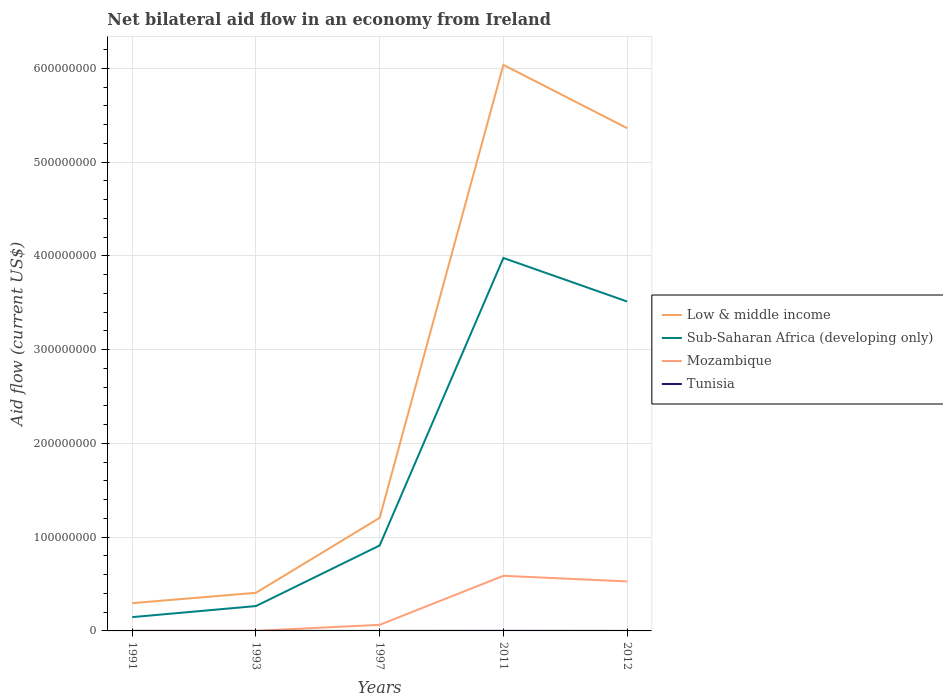Does the line corresponding to Mozambique intersect with the line corresponding to Low & middle income?
Keep it short and to the point. No. Is the number of lines equal to the number of legend labels?
Keep it short and to the point. Yes. In which year was the net bilateral aid flow in Mozambique maximum?
Make the answer very short. 1991. What is the total net bilateral aid flow in Low & middle income in the graph?
Offer a very short reply. -8.00e+07. What is the difference between the highest and the second highest net bilateral aid flow in Mozambique?
Your answer should be very brief. 5.87e+07. Is the net bilateral aid flow in Mozambique strictly greater than the net bilateral aid flow in Sub-Saharan Africa (developing only) over the years?
Your response must be concise. Yes. How many lines are there?
Ensure brevity in your answer.  4. Are the values on the major ticks of Y-axis written in scientific E-notation?
Offer a very short reply. No. Where does the legend appear in the graph?
Make the answer very short. Center right. How many legend labels are there?
Offer a terse response. 4. What is the title of the graph?
Your answer should be very brief. Net bilateral aid flow in an economy from Ireland. What is the label or title of the X-axis?
Your answer should be compact. Years. What is the Aid flow (current US$) in Low & middle income in 1991?
Give a very brief answer. 2.96e+07. What is the Aid flow (current US$) of Sub-Saharan Africa (developing only) in 1991?
Make the answer very short. 1.47e+07. What is the Aid flow (current US$) of Mozambique in 1991?
Give a very brief answer. 1.00e+05. What is the Aid flow (current US$) of Tunisia in 1991?
Make the answer very short. 10000. What is the Aid flow (current US$) of Low & middle income in 1993?
Offer a terse response. 4.07e+07. What is the Aid flow (current US$) of Sub-Saharan Africa (developing only) in 1993?
Your answer should be very brief. 2.65e+07. What is the Aid flow (current US$) of Tunisia in 1993?
Keep it short and to the point. 10000. What is the Aid flow (current US$) of Low & middle income in 1997?
Offer a terse response. 1.21e+08. What is the Aid flow (current US$) in Sub-Saharan Africa (developing only) in 1997?
Give a very brief answer. 9.11e+07. What is the Aid flow (current US$) in Mozambique in 1997?
Make the answer very short. 6.48e+06. What is the Aid flow (current US$) in Tunisia in 1997?
Your answer should be compact. 2.00e+04. What is the Aid flow (current US$) in Low & middle income in 2011?
Make the answer very short. 6.04e+08. What is the Aid flow (current US$) in Sub-Saharan Africa (developing only) in 2011?
Your answer should be compact. 3.98e+08. What is the Aid flow (current US$) in Mozambique in 2011?
Keep it short and to the point. 5.88e+07. What is the Aid flow (current US$) of Tunisia in 2011?
Offer a very short reply. 8.00e+04. What is the Aid flow (current US$) of Low & middle income in 2012?
Your response must be concise. 5.36e+08. What is the Aid flow (current US$) in Sub-Saharan Africa (developing only) in 2012?
Offer a terse response. 3.51e+08. What is the Aid flow (current US$) in Mozambique in 2012?
Give a very brief answer. 5.28e+07. Across all years, what is the maximum Aid flow (current US$) of Low & middle income?
Your response must be concise. 6.04e+08. Across all years, what is the maximum Aid flow (current US$) in Sub-Saharan Africa (developing only)?
Make the answer very short. 3.98e+08. Across all years, what is the maximum Aid flow (current US$) of Mozambique?
Provide a succinct answer. 5.88e+07. Across all years, what is the maximum Aid flow (current US$) of Tunisia?
Make the answer very short. 8.00e+04. Across all years, what is the minimum Aid flow (current US$) of Low & middle income?
Provide a short and direct response. 2.96e+07. Across all years, what is the minimum Aid flow (current US$) of Sub-Saharan Africa (developing only)?
Offer a very short reply. 1.47e+07. Across all years, what is the minimum Aid flow (current US$) of Tunisia?
Your answer should be very brief. 10000. What is the total Aid flow (current US$) in Low & middle income in the graph?
Give a very brief answer. 1.33e+09. What is the total Aid flow (current US$) in Sub-Saharan Africa (developing only) in the graph?
Give a very brief answer. 8.81e+08. What is the total Aid flow (current US$) in Mozambique in the graph?
Keep it short and to the point. 1.18e+08. What is the total Aid flow (current US$) of Tunisia in the graph?
Offer a very short reply. 1.30e+05. What is the difference between the Aid flow (current US$) of Low & middle income in 1991 and that in 1993?
Make the answer very short. -1.10e+07. What is the difference between the Aid flow (current US$) in Sub-Saharan Africa (developing only) in 1991 and that in 1993?
Ensure brevity in your answer.  -1.18e+07. What is the difference between the Aid flow (current US$) of Tunisia in 1991 and that in 1993?
Your answer should be very brief. 0. What is the difference between the Aid flow (current US$) of Low & middle income in 1991 and that in 1997?
Give a very brief answer. -9.10e+07. What is the difference between the Aid flow (current US$) in Sub-Saharan Africa (developing only) in 1991 and that in 1997?
Your response must be concise. -7.64e+07. What is the difference between the Aid flow (current US$) in Mozambique in 1991 and that in 1997?
Offer a very short reply. -6.38e+06. What is the difference between the Aid flow (current US$) in Tunisia in 1991 and that in 1997?
Your answer should be very brief. -10000. What is the difference between the Aid flow (current US$) in Low & middle income in 1991 and that in 2011?
Give a very brief answer. -5.74e+08. What is the difference between the Aid flow (current US$) in Sub-Saharan Africa (developing only) in 1991 and that in 2011?
Make the answer very short. -3.83e+08. What is the difference between the Aid flow (current US$) in Mozambique in 1991 and that in 2011?
Keep it short and to the point. -5.87e+07. What is the difference between the Aid flow (current US$) in Tunisia in 1991 and that in 2011?
Your response must be concise. -7.00e+04. What is the difference between the Aid flow (current US$) of Low & middle income in 1991 and that in 2012?
Make the answer very short. -5.07e+08. What is the difference between the Aid flow (current US$) of Sub-Saharan Africa (developing only) in 1991 and that in 2012?
Provide a short and direct response. -3.37e+08. What is the difference between the Aid flow (current US$) of Mozambique in 1991 and that in 2012?
Keep it short and to the point. -5.27e+07. What is the difference between the Aid flow (current US$) of Tunisia in 1991 and that in 2012?
Provide a succinct answer. 0. What is the difference between the Aid flow (current US$) of Low & middle income in 1993 and that in 1997?
Ensure brevity in your answer.  -8.00e+07. What is the difference between the Aid flow (current US$) of Sub-Saharan Africa (developing only) in 1993 and that in 1997?
Ensure brevity in your answer.  -6.46e+07. What is the difference between the Aid flow (current US$) of Mozambique in 1993 and that in 1997?
Give a very brief answer. -6.36e+06. What is the difference between the Aid flow (current US$) in Low & middle income in 1993 and that in 2011?
Give a very brief answer. -5.63e+08. What is the difference between the Aid flow (current US$) of Sub-Saharan Africa (developing only) in 1993 and that in 2011?
Offer a terse response. -3.71e+08. What is the difference between the Aid flow (current US$) of Mozambique in 1993 and that in 2011?
Your response must be concise. -5.87e+07. What is the difference between the Aid flow (current US$) of Low & middle income in 1993 and that in 2012?
Provide a succinct answer. -4.96e+08. What is the difference between the Aid flow (current US$) in Sub-Saharan Africa (developing only) in 1993 and that in 2012?
Your answer should be very brief. -3.25e+08. What is the difference between the Aid flow (current US$) of Mozambique in 1993 and that in 2012?
Make the answer very short. -5.27e+07. What is the difference between the Aid flow (current US$) in Tunisia in 1993 and that in 2012?
Keep it short and to the point. 0. What is the difference between the Aid flow (current US$) in Low & middle income in 1997 and that in 2011?
Your answer should be compact. -4.83e+08. What is the difference between the Aid flow (current US$) of Sub-Saharan Africa (developing only) in 1997 and that in 2011?
Offer a very short reply. -3.07e+08. What is the difference between the Aid flow (current US$) of Mozambique in 1997 and that in 2011?
Your response must be concise. -5.23e+07. What is the difference between the Aid flow (current US$) in Low & middle income in 1997 and that in 2012?
Offer a very short reply. -4.16e+08. What is the difference between the Aid flow (current US$) of Sub-Saharan Africa (developing only) in 1997 and that in 2012?
Provide a short and direct response. -2.60e+08. What is the difference between the Aid flow (current US$) in Mozambique in 1997 and that in 2012?
Your response must be concise. -4.63e+07. What is the difference between the Aid flow (current US$) of Low & middle income in 2011 and that in 2012?
Give a very brief answer. 6.75e+07. What is the difference between the Aid flow (current US$) of Sub-Saharan Africa (developing only) in 2011 and that in 2012?
Give a very brief answer. 4.64e+07. What is the difference between the Aid flow (current US$) of Mozambique in 2011 and that in 2012?
Offer a terse response. 5.98e+06. What is the difference between the Aid flow (current US$) in Low & middle income in 1991 and the Aid flow (current US$) in Sub-Saharan Africa (developing only) in 1993?
Offer a terse response. 3.12e+06. What is the difference between the Aid flow (current US$) in Low & middle income in 1991 and the Aid flow (current US$) in Mozambique in 1993?
Offer a terse response. 2.95e+07. What is the difference between the Aid flow (current US$) of Low & middle income in 1991 and the Aid flow (current US$) of Tunisia in 1993?
Keep it short and to the point. 2.96e+07. What is the difference between the Aid flow (current US$) of Sub-Saharan Africa (developing only) in 1991 and the Aid flow (current US$) of Mozambique in 1993?
Keep it short and to the point. 1.46e+07. What is the difference between the Aid flow (current US$) of Sub-Saharan Africa (developing only) in 1991 and the Aid flow (current US$) of Tunisia in 1993?
Provide a short and direct response. 1.47e+07. What is the difference between the Aid flow (current US$) in Mozambique in 1991 and the Aid flow (current US$) in Tunisia in 1993?
Provide a short and direct response. 9.00e+04. What is the difference between the Aid flow (current US$) in Low & middle income in 1991 and the Aid flow (current US$) in Sub-Saharan Africa (developing only) in 1997?
Your answer should be very brief. -6.15e+07. What is the difference between the Aid flow (current US$) of Low & middle income in 1991 and the Aid flow (current US$) of Mozambique in 1997?
Offer a very short reply. 2.32e+07. What is the difference between the Aid flow (current US$) of Low & middle income in 1991 and the Aid flow (current US$) of Tunisia in 1997?
Your response must be concise. 2.96e+07. What is the difference between the Aid flow (current US$) in Sub-Saharan Africa (developing only) in 1991 and the Aid flow (current US$) in Mozambique in 1997?
Provide a short and direct response. 8.24e+06. What is the difference between the Aid flow (current US$) of Sub-Saharan Africa (developing only) in 1991 and the Aid flow (current US$) of Tunisia in 1997?
Ensure brevity in your answer.  1.47e+07. What is the difference between the Aid flow (current US$) in Low & middle income in 1991 and the Aid flow (current US$) in Sub-Saharan Africa (developing only) in 2011?
Your answer should be very brief. -3.68e+08. What is the difference between the Aid flow (current US$) in Low & middle income in 1991 and the Aid flow (current US$) in Mozambique in 2011?
Provide a short and direct response. -2.92e+07. What is the difference between the Aid flow (current US$) in Low & middle income in 1991 and the Aid flow (current US$) in Tunisia in 2011?
Your answer should be very brief. 2.96e+07. What is the difference between the Aid flow (current US$) in Sub-Saharan Africa (developing only) in 1991 and the Aid flow (current US$) in Mozambique in 2011?
Your response must be concise. -4.41e+07. What is the difference between the Aid flow (current US$) of Sub-Saharan Africa (developing only) in 1991 and the Aid flow (current US$) of Tunisia in 2011?
Your answer should be compact. 1.46e+07. What is the difference between the Aid flow (current US$) of Mozambique in 1991 and the Aid flow (current US$) of Tunisia in 2011?
Keep it short and to the point. 2.00e+04. What is the difference between the Aid flow (current US$) of Low & middle income in 1991 and the Aid flow (current US$) of Sub-Saharan Africa (developing only) in 2012?
Your answer should be compact. -3.22e+08. What is the difference between the Aid flow (current US$) in Low & middle income in 1991 and the Aid flow (current US$) in Mozambique in 2012?
Offer a very short reply. -2.32e+07. What is the difference between the Aid flow (current US$) in Low & middle income in 1991 and the Aid flow (current US$) in Tunisia in 2012?
Make the answer very short. 2.96e+07. What is the difference between the Aid flow (current US$) of Sub-Saharan Africa (developing only) in 1991 and the Aid flow (current US$) of Mozambique in 2012?
Provide a short and direct response. -3.81e+07. What is the difference between the Aid flow (current US$) of Sub-Saharan Africa (developing only) in 1991 and the Aid flow (current US$) of Tunisia in 2012?
Make the answer very short. 1.47e+07. What is the difference between the Aid flow (current US$) in Mozambique in 1991 and the Aid flow (current US$) in Tunisia in 2012?
Your answer should be compact. 9.00e+04. What is the difference between the Aid flow (current US$) in Low & middle income in 1993 and the Aid flow (current US$) in Sub-Saharan Africa (developing only) in 1997?
Ensure brevity in your answer.  -5.05e+07. What is the difference between the Aid flow (current US$) of Low & middle income in 1993 and the Aid flow (current US$) of Mozambique in 1997?
Give a very brief answer. 3.42e+07. What is the difference between the Aid flow (current US$) of Low & middle income in 1993 and the Aid flow (current US$) of Tunisia in 1997?
Your answer should be very brief. 4.06e+07. What is the difference between the Aid flow (current US$) of Sub-Saharan Africa (developing only) in 1993 and the Aid flow (current US$) of Mozambique in 1997?
Give a very brief answer. 2.00e+07. What is the difference between the Aid flow (current US$) in Sub-Saharan Africa (developing only) in 1993 and the Aid flow (current US$) in Tunisia in 1997?
Make the answer very short. 2.65e+07. What is the difference between the Aid flow (current US$) of Mozambique in 1993 and the Aid flow (current US$) of Tunisia in 1997?
Your answer should be compact. 1.00e+05. What is the difference between the Aid flow (current US$) in Low & middle income in 1993 and the Aid flow (current US$) in Sub-Saharan Africa (developing only) in 2011?
Keep it short and to the point. -3.57e+08. What is the difference between the Aid flow (current US$) in Low & middle income in 1993 and the Aid flow (current US$) in Mozambique in 2011?
Your response must be concise. -1.81e+07. What is the difference between the Aid flow (current US$) in Low & middle income in 1993 and the Aid flow (current US$) in Tunisia in 2011?
Keep it short and to the point. 4.06e+07. What is the difference between the Aid flow (current US$) of Sub-Saharan Africa (developing only) in 1993 and the Aid flow (current US$) of Mozambique in 2011?
Your response must be concise. -3.23e+07. What is the difference between the Aid flow (current US$) of Sub-Saharan Africa (developing only) in 1993 and the Aid flow (current US$) of Tunisia in 2011?
Your answer should be very brief. 2.64e+07. What is the difference between the Aid flow (current US$) of Mozambique in 1993 and the Aid flow (current US$) of Tunisia in 2011?
Give a very brief answer. 4.00e+04. What is the difference between the Aid flow (current US$) of Low & middle income in 1993 and the Aid flow (current US$) of Sub-Saharan Africa (developing only) in 2012?
Your answer should be compact. -3.11e+08. What is the difference between the Aid flow (current US$) of Low & middle income in 1993 and the Aid flow (current US$) of Mozambique in 2012?
Keep it short and to the point. -1.21e+07. What is the difference between the Aid flow (current US$) in Low & middle income in 1993 and the Aid flow (current US$) in Tunisia in 2012?
Your response must be concise. 4.06e+07. What is the difference between the Aid flow (current US$) in Sub-Saharan Africa (developing only) in 1993 and the Aid flow (current US$) in Mozambique in 2012?
Give a very brief answer. -2.63e+07. What is the difference between the Aid flow (current US$) of Sub-Saharan Africa (developing only) in 1993 and the Aid flow (current US$) of Tunisia in 2012?
Offer a terse response. 2.65e+07. What is the difference between the Aid flow (current US$) in Low & middle income in 1997 and the Aid flow (current US$) in Sub-Saharan Africa (developing only) in 2011?
Ensure brevity in your answer.  -2.77e+08. What is the difference between the Aid flow (current US$) of Low & middle income in 1997 and the Aid flow (current US$) of Mozambique in 2011?
Give a very brief answer. 6.18e+07. What is the difference between the Aid flow (current US$) of Low & middle income in 1997 and the Aid flow (current US$) of Tunisia in 2011?
Your response must be concise. 1.21e+08. What is the difference between the Aid flow (current US$) in Sub-Saharan Africa (developing only) in 1997 and the Aid flow (current US$) in Mozambique in 2011?
Provide a succinct answer. 3.24e+07. What is the difference between the Aid flow (current US$) of Sub-Saharan Africa (developing only) in 1997 and the Aid flow (current US$) of Tunisia in 2011?
Offer a very short reply. 9.10e+07. What is the difference between the Aid flow (current US$) of Mozambique in 1997 and the Aid flow (current US$) of Tunisia in 2011?
Your answer should be very brief. 6.40e+06. What is the difference between the Aid flow (current US$) in Low & middle income in 1997 and the Aid flow (current US$) in Sub-Saharan Africa (developing only) in 2012?
Ensure brevity in your answer.  -2.31e+08. What is the difference between the Aid flow (current US$) in Low & middle income in 1997 and the Aid flow (current US$) in Mozambique in 2012?
Provide a succinct answer. 6.78e+07. What is the difference between the Aid flow (current US$) of Low & middle income in 1997 and the Aid flow (current US$) of Tunisia in 2012?
Offer a very short reply. 1.21e+08. What is the difference between the Aid flow (current US$) of Sub-Saharan Africa (developing only) in 1997 and the Aid flow (current US$) of Mozambique in 2012?
Offer a very short reply. 3.83e+07. What is the difference between the Aid flow (current US$) of Sub-Saharan Africa (developing only) in 1997 and the Aid flow (current US$) of Tunisia in 2012?
Offer a terse response. 9.11e+07. What is the difference between the Aid flow (current US$) of Mozambique in 1997 and the Aid flow (current US$) of Tunisia in 2012?
Your response must be concise. 6.47e+06. What is the difference between the Aid flow (current US$) in Low & middle income in 2011 and the Aid flow (current US$) in Sub-Saharan Africa (developing only) in 2012?
Your answer should be compact. 2.52e+08. What is the difference between the Aid flow (current US$) of Low & middle income in 2011 and the Aid flow (current US$) of Mozambique in 2012?
Offer a very short reply. 5.51e+08. What is the difference between the Aid flow (current US$) of Low & middle income in 2011 and the Aid flow (current US$) of Tunisia in 2012?
Your answer should be very brief. 6.04e+08. What is the difference between the Aid flow (current US$) of Sub-Saharan Africa (developing only) in 2011 and the Aid flow (current US$) of Mozambique in 2012?
Your response must be concise. 3.45e+08. What is the difference between the Aid flow (current US$) of Sub-Saharan Africa (developing only) in 2011 and the Aid flow (current US$) of Tunisia in 2012?
Offer a very short reply. 3.98e+08. What is the difference between the Aid flow (current US$) of Mozambique in 2011 and the Aid flow (current US$) of Tunisia in 2012?
Provide a succinct answer. 5.88e+07. What is the average Aid flow (current US$) of Low & middle income per year?
Offer a very short reply. 2.66e+08. What is the average Aid flow (current US$) of Sub-Saharan Africa (developing only) per year?
Give a very brief answer. 1.76e+08. What is the average Aid flow (current US$) in Mozambique per year?
Your answer should be compact. 2.37e+07. What is the average Aid flow (current US$) in Tunisia per year?
Make the answer very short. 2.60e+04. In the year 1991, what is the difference between the Aid flow (current US$) in Low & middle income and Aid flow (current US$) in Sub-Saharan Africa (developing only)?
Provide a succinct answer. 1.49e+07. In the year 1991, what is the difference between the Aid flow (current US$) in Low & middle income and Aid flow (current US$) in Mozambique?
Provide a succinct answer. 2.95e+07. In the year 1991, what is the difference between the Aid flow (current US$) in Low & middle income and Aid flow (current US$) in Tunisia?
Provide a short and direct response. 2.96e+07. In the year 1991, what is the difference between the Aid flow (current US$) of Sub-Saharan Africa (developing only) and Aid flow (current US$) of Mozambique?
Provide a short and direct response. 1.46e+07. In the year 1991, what is the difference between the Aid flow (current US$) in Sub-Saharan Africa (developing only) and Aid flow (current US$) in Tunisia?
Your answer should be compact. 1.47e+07. In the year 1991, what is the difference between the Aid flow (current US$) of Mozambique and Aid flow (current US$) of Tunisia?
Provide a succinct answer. 9.00e+04. In the year 1993, what is the difference between the Aid flow (current US$) in Low & middle income and Aid flow (current US$) in Sub-Saharan Africa (developing only)?
Give a very brief answer. 1.42e+07. In the year 1993, what is the difference between the Aid flow (current US$) in Low & middle income and Aid flow (current US$) in Mozambique?
Offer a terse response. 4.05e+07. In the year 1993, what is the difference between the Aid flow (current US$) in Low & middle income and Aid flow (current US$) in Tunisia?
Provide a short and direct response. 4.06e+07. In the year 1993, what is the difference between the Aid flow (current US$) of Sub-Saharan Africa (developing only) and Aid flow (current US$) of Mozambique?
Your response must be concise. 2.64e+07. In the year 1993, what is the difference between the Aid flow (current US$) of Sub-Saharan Africa (developing only) and Aid flow (current US$) of Tunisia?
Offer a terse response. 2.65e+07. In the year 1993, what is the difference between the Aid flow (current US$) of Mozambique and Aid flow (current US$) of Tunisia?
Your answer should be compact. 1.10e+05. In the year 1997, what is the difference between the Aid flow (current US$) of Low & middle income and Aid flow (current US$) of Sub-Saharan Africa (developing only)?
Your response must be concise. 2.95e+07. In the year 1997, what is the difference between the Aid flow (current US$) in Low & middle income and Aid flow (current US$) in Mozambique?
Your response must be concise. 1.14e+08. In the year 1997, what is the difference between the Aid flow (current US$) of Low & middle income and Aid flow (current US$) of Tunisia?
Provide a short and direct response. 1.21e+08. In the year 1997, what is the difference between the Aid flow (current US$) in Sub-Saharan Africa (developing only) and Aid flow (current US$) in Mozambique?
Your response must be concise. 8.46e+07. In the year 1997, what is the difference between the Aid flow (current US$) of Sub-Saharan Africa (developing only) and Aid flow (current US$) of Tunisia?
Provide a short and direct response. 9.11e+07. In the year 1997, what is the difference between the Aid flow (current US$) of Mozambique and Aid flow (current US$) of Tunisia?
Offer a terse response. 6.46e+06. In the year 2011, what is the difference between the Aid flow (current US$) in Low & middle income and Aid flow (current US$) in Sub-Saharan Africa (developing only)?
Provide a short and direct response. 2.06e+08. In the year 2011, what is the difference between the Aid flow (current US$) in Low & middle income and Aid flow (current US$) in Mozambique?
Provide a succinct answer. 5.45e+08. In the year 2011, what is the difference between the Aid flow (current US$) in Low & middle income and Aid flow (current US$) in Tunisia?
Your answer should be compact. 6.04e+08. In the year 2011, what is the difference between the Aid flow (current US$) of Sub-Saharan Africa (developing only) and Aid flow (current US$) of Mozambique?
Offer a very short reply. 3.39e+08. In the year 2011, what is the difference between the Aid flow (current US$) of Sub-Saharan Africa (developing only) and Aid flow (current US$) of Tunisia?
Make the answer very short. 3.98e+08. In the year 2011, what is the difference between the Aid flow (current US$) of Mozambique and Aid flow (current US$) of Tunisia?
Provide a succinct answer. 5.87e+07. In the year 2012, what is the difference between the Aid flow (current US$) in Low & middle income and Aid flow (current US$) in Sub-Saharan Africa (developing only)?
Provide a short and direct response. 1.85e+08. In the year 2012, what is the difference between the Aid flow (current US$) in Low & middle income and Aid flow (current US$) in Mozambique?
Provide a succinct answer. 4.83e+08. In the year 2012, what is the difference between the Aid flow (current US$) in Low & middle income and Aid flow (current US$) in Tunisia?
Ensure brevity in your answer.  5.36e+08. In the year 2012, what is the difference between the Aid flow (current US$) of Sub-Saharan Africa (developing only) and Aid flow (current US$) of Mozambique?
Keep it short and to the point. 2.99e+08. In the year 2012, what is the difference between the Aid flow (current US$) of Sub-Saharan Africa (developing only) and Aid flow (current US$) of Tunisia?
Provide a succinct answer. 3.51e+08. In the year 2012, what is the difference between the Aid flow (current US$) in Mozambique and Aid flow (current US$) in Tunisia?
Offer a very short reply. 5.28e+07. What is the ratio of the Aid flow (current US$) in Low & middle income in 1991 to that in 1993?
Provide a succinct answer. 0.73. What is the ratio of the Aid flow (current US$) of Sub-Saharan Africa (developing only) in 1991 to that in 1993?
Provide a succinct answer. 0.56. What is the ratio of the Aid flow (current US$) of Tunisia in 1991 to that in 1993?
Give a very brief answer. 1. What is the ratio of the Aid flow (current US$) of Low & middle income in 1991 to that in 1997?
Make the answer very short. 0.25. What is the ratio of the Aid flow (current US$) of Sub-Saharan Africa (developing only) in 1991 to that in 1997?
Offer a very short reply. 0.16. What is the ratio of the Aid flow (current US$) of Mozambique in 1991 to that in 1997?
Your answer should be compact. 0.02. What is the ratio of the Aid flow (current US$) of Low & middle income in 1991 to that in 2011?
Give a very brief answer. 0.05. What is the ratio of the Aid flow (current US$) in Sub-Saharan Africa (developing only) in 1991 to that in 2011?
Your answer should be very brief. 0.04. What is the ratio of the Aid flow (current US$) of Mozambique in 1991 to that in 2011?
Offer a very short reply. 0. What is the ratio of the Aid flow (current US$) in Tunisia in 1991 to that in 2011?
Keep it short and to the point. 0.12. What is the ratio of the Aid flow (current US$) of Low & middle income in 1991 to that in 2012?
Offer a very short reply. 0.06. What is the ratio of the Aid flow (current US$) in Sub-Saharan Africa (developing only) in 1991 to that in 2012?
Provide a short and direct response. 0.04. What is the ratio of the Aid flow (current US$) in Mozambique in 1991 to that in 2012?
Your answer should be very brief. 0. What is the ratio of the Aid flow (current US$) of Low & middle income in 1993 to that in 1997?
Make the answer very short. 0.34. What is the ratio of the Aid flow (current US$) in Sub-Saharan Africa (developing only) in 1993 to that in 1997?
Keep it short and to the point. 0.29. What is the ratio of the Aid flow (current US$) of Mozambique in 1993 to that in 1997?
Your answer should be compact. 0.02. What is the ratio of the Aid flow (current US$) of Tunisia in 1993 to that in 1997?
Provide a succinct answer. 0.5. What is the ratio of the Aid flow (current US$) of Low & middle income in 1993 to that in 2011?
Provide a short and direct response. 0.07. What is the ratio of the Aid flow (current US$) of Sub-Saharan Africa (developing only) in 1993 to that in 2011?
Keep it short and to the point. 0.07. What is the ratio of the Aid flow (current US$) in Mozambique in 1993 to that in 2011?
Your answer should be compact. 0. What is the ratio of the Aid flow (current US$) of Tunisia in 1993 to that in 2011?
Make the answer very short. 0.12. What is the ratio of the Aid flow (current US$) of Low & middle income in 1993 to that in 2012?
Your answer should be compact. 0.08. What is the ratio of the Aid flow (current US$) of Sub-Saharan Africa (developing only) in 1993 to that in 2012?
Provide a short and direct response. 0.08. What is the ratio of the Aid flow (current US$) in Mozambique in 1993 to that in 2012?
Your answer should be compact. 0. What is the ratio of the Aid flow (current US$) of Low & middle income in 1997 to that in 2011?
Your response must be concise. 0.2. What is the ratio of the Aid flow (current US$) in Sub-Saharan Africa (developing only) in 1997 to that in 2011?
Provide a succinct answer. 0.23. What is the ratio of the Aid flow (current US$) in Mozambique in 1997 to that in 2011?
Offer a terse response. 0.11. What is the ratio of the Aid flow (current US$) of Low & middle income in 1997 to that in 2012?
Offer a terse response. 0.23. What is the ratio of the Aid flow (current US$) of Sub-Saharan Africa (developing only) in 1997 to that in 2012?
Keep it short and to the point. 0.26. What is the ratio of the Aid flow (current US$) in Mozambique in 1997 to that in 2012?
Provide a short and direct response. 0.12. What is the ratio of the Aid flow (current US$) in Low & middle income in 2011 to that in 2012?
Your response must be concise. 1.13. What is the ratio of the Aid flow (current US$) in Sub-Saharan Africa (developing only) in 2011 to that in 2012?
Give a very brief answer. 1.13. What is the ratio of the Aid flow (current US$) in Mozambique in 2011 to that in 2012?
Offer a very short reply. 1.11. What is the ratio of the Aid flow (current US$) in Tunisia in 2011 to that in 2012?
Give a very brief answer. 8. What is the difference between the highest and the second highest Aid flow (current US$) in Low & middle income?
Your answer should be very brief. 6.75e+07. What is the difference between the highest and the second highest Aid flow (current US$) in Sub-Saharan Africa (developing only)?
Provide a short and direct response. 4.64e+07. What is the difference between the highest and the second highest Aid flow (current US$) in Mozambique?
Your response must be concise. 5.98e+06. What is the difference between the highest and the lowest Aid flow (current US$) of Low & middle income?
Provide a succinct answer. 5.74e+08. What is the difference between the highest and the lowest Aid flow (current US$) of Sub-Saharan Africa (developing only)?
Ensure brevity in your answer.  3.83e+08. What is the difference between the highest and the lowest Aid flow (current US$) of Mozambique?
Your answer should be compact. 5.87e+07. 